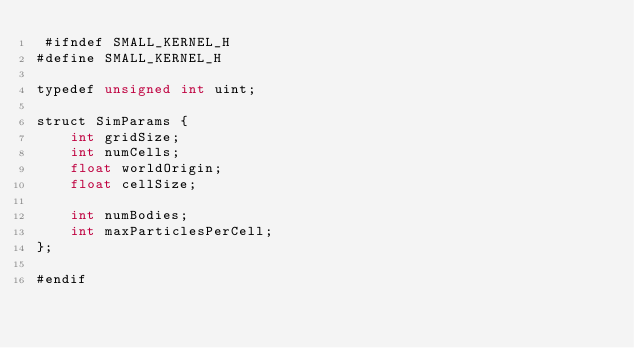Convert code to text. <code><loc_0><loc_0><loc_500><loc_500><_Cuda_> #ifndef SMALL_KERNEL_H
#define SMALL_KERNEL_H

typedef unsigned int uint;

struct SimParams {
    int gridSize;
    int numCells;
    float worldOrigin;
    float cellSize;

    int numBodies;
    int maxParticlesPerCell;
};

#endif
</code> 